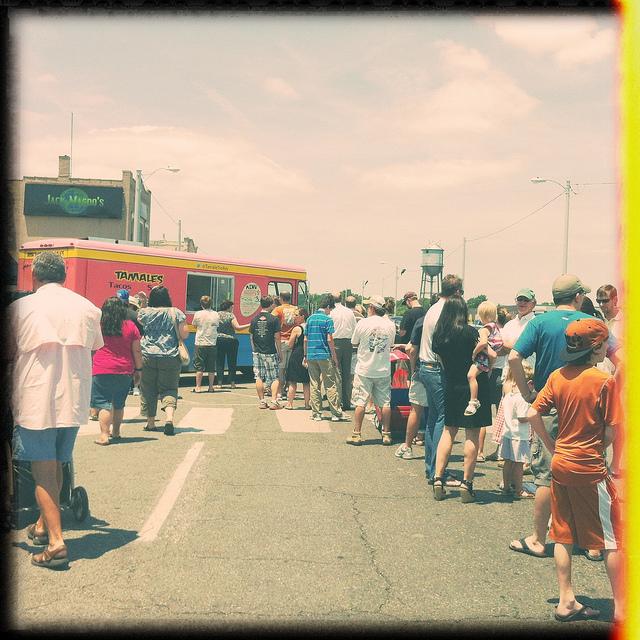What color is the food truck?
Write a very short answer. Pink. Where are the people looking?
Short answer required. At truck. Is there a water tower?
Quick response, please. Yes. What time of year do you think it is?
Be succinct. Summer. 